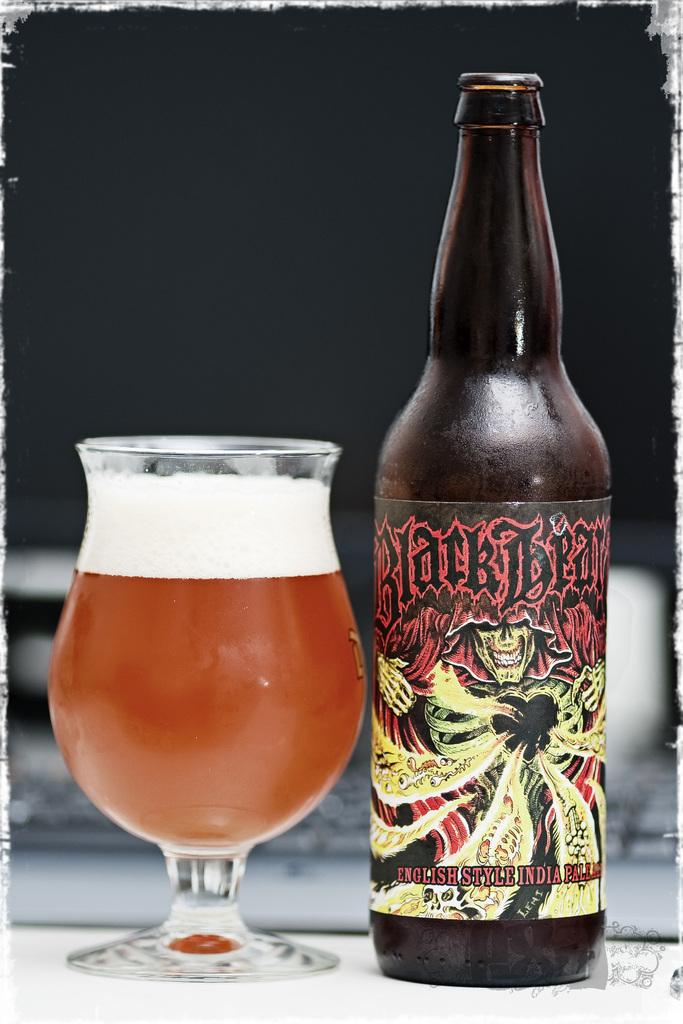<image>
Share a concise interpretation of the image provided. Bottle of Blackbeard English Style Pale Ale beside a full glass. 